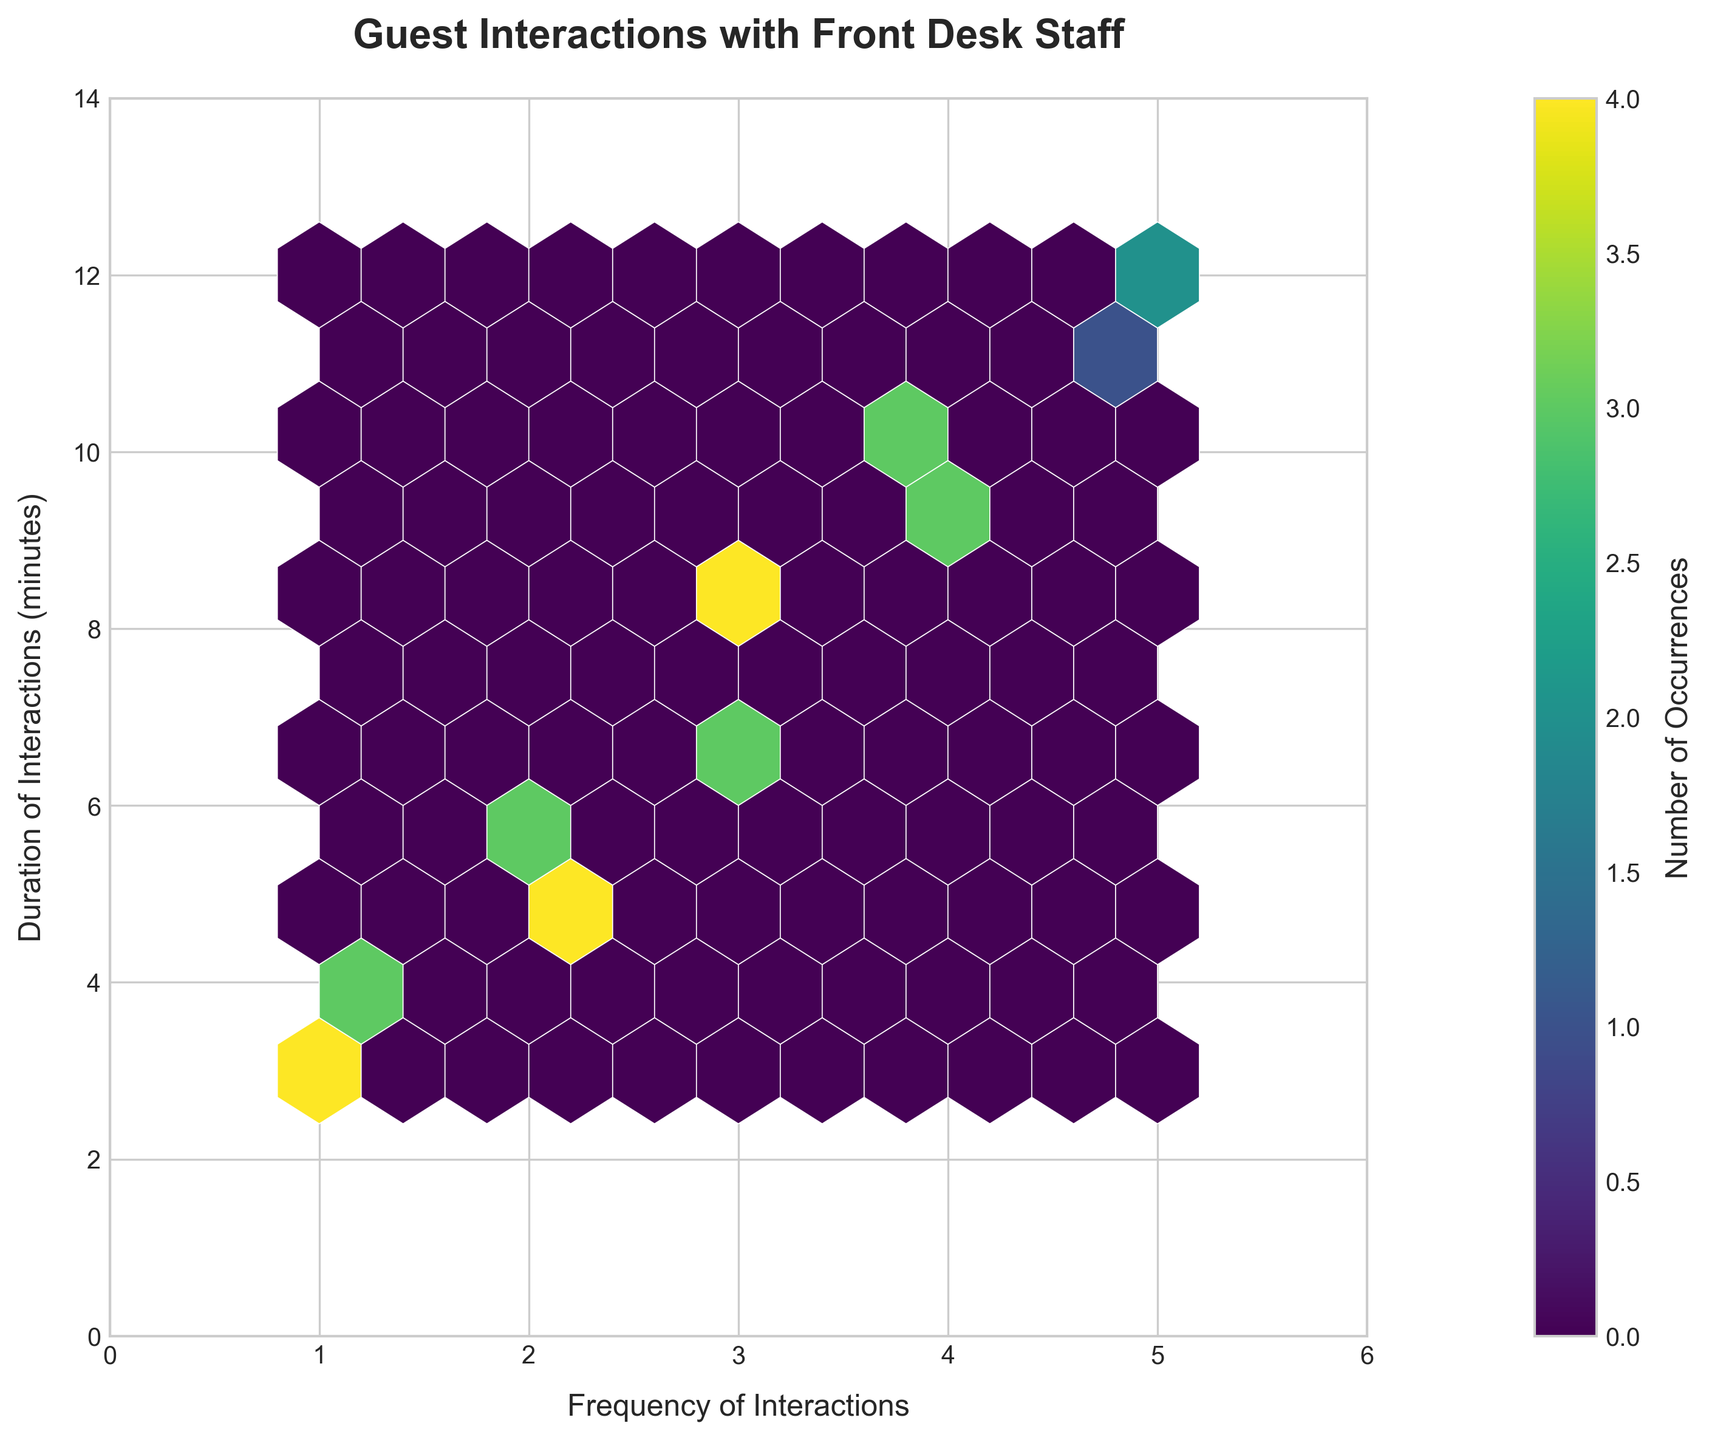What is the title of the plot? The title is located at the top of the plot and is in bold, large font. It is meant to concisely describe the content or purpose of the plot.
Answer: Guest Interactions with Front Desk Staff What is the color map used in the plot? The color map helps to display the intensity or frequency of data occurrences in different shades. In this plot, the color map is easy to identify as it transitions from lighter to darker shades.
Answer: viridis What are the labels on the x and y axes? The x and y axis labels can be found just below and to the left of the respective axes. They describe what each axis represents.
Answer: Frequency of Interactions (x) and Duration of Interactions (minutes) (y) What does a darker hexagon signify in this plot? Darker hexagons in a hexbin plot indicate a higher density of data points in that region. This color coding helps to easily identify areas with more frequent occurrences.
Answer: Higher density What is the range of the x-axis and y-axis? Observing the limits set on both axes, the x-axis range can be identified from 0 to just above the maximum frequency value, and similarly for the y-axis.
Answer: x-axis: 0 to 6, y-axis: 0 to 14 Which bins have the highest density of occurrences? In a hexbin plot, the bins with the highest density are the darkest. Locating the darkest hexagons in the plot indicates where the highest number of occurrences is found.
Answer: Around (2, 5-6) and (3, 7-8) What can be inferred about interactions that last longer than 10 minutes? By analyzing the distribution of data points along the y-axis, particularly looking for the locations of hexagons corresponding to durations above 10, we can make inferences about such interactions.
Answer: They are less frequent How does the frequency of interactions relate to the duration of interactions? A general pattern can be observed by examining the spread and central tendency of hexagons along both axes, giving an insight into whether there is any correlation between frequency and duration.
Answer: Higher frequency tends to have longer duration What is the relationship between guest interactions that occur exactly 3 times and their duration? By specifically focusing on the column of hexagons where the frequency is 3 and observing the vertical placement, one can determine the typical durations associated with this frequency.
Answer: Mostly around 7-8 minutes Do any interactions last exactly 12 minutes, and if so, how frequent are they? Finding the row in the plot that corresponds to a y value of 12 minutes and examining the number of hexagons and their darkness in that row will provide this information.
Answer: Yes, they are infrequent and correspond to frequency 5 